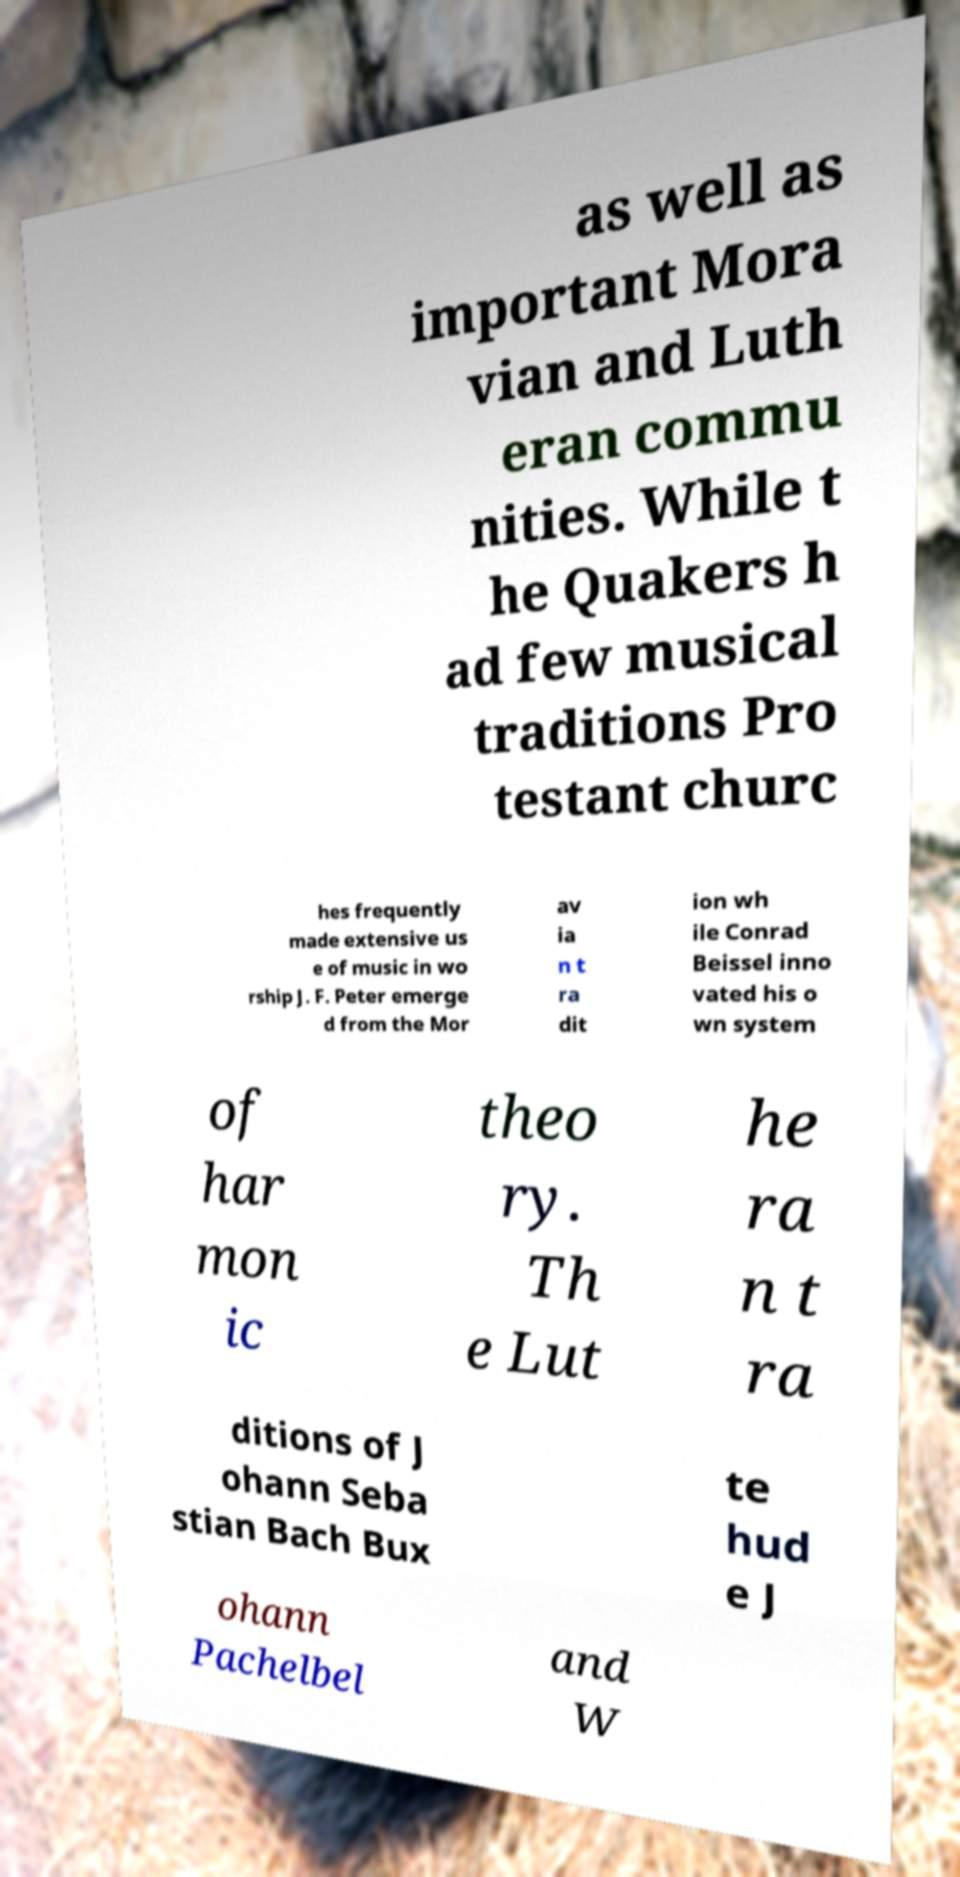There's text embedded in this image that I need extracted. Can you transcribe it verbatim? as well as important Mora vian and Luth eran commu nities. While t he Quakers h ad few musical traditions Pro testant churc hes frequently made extensive us e of music in wo rship J. F. Peter emerge d from the Mor av ia n t ra dit ion wh ile Conrad Beissel inno vated his o wn system of har mon ic theo ry. Th e Lut he ra n t ra ditions of J ohann Seba stian Bach Bux te hud e J ohann Pachelbel and W 